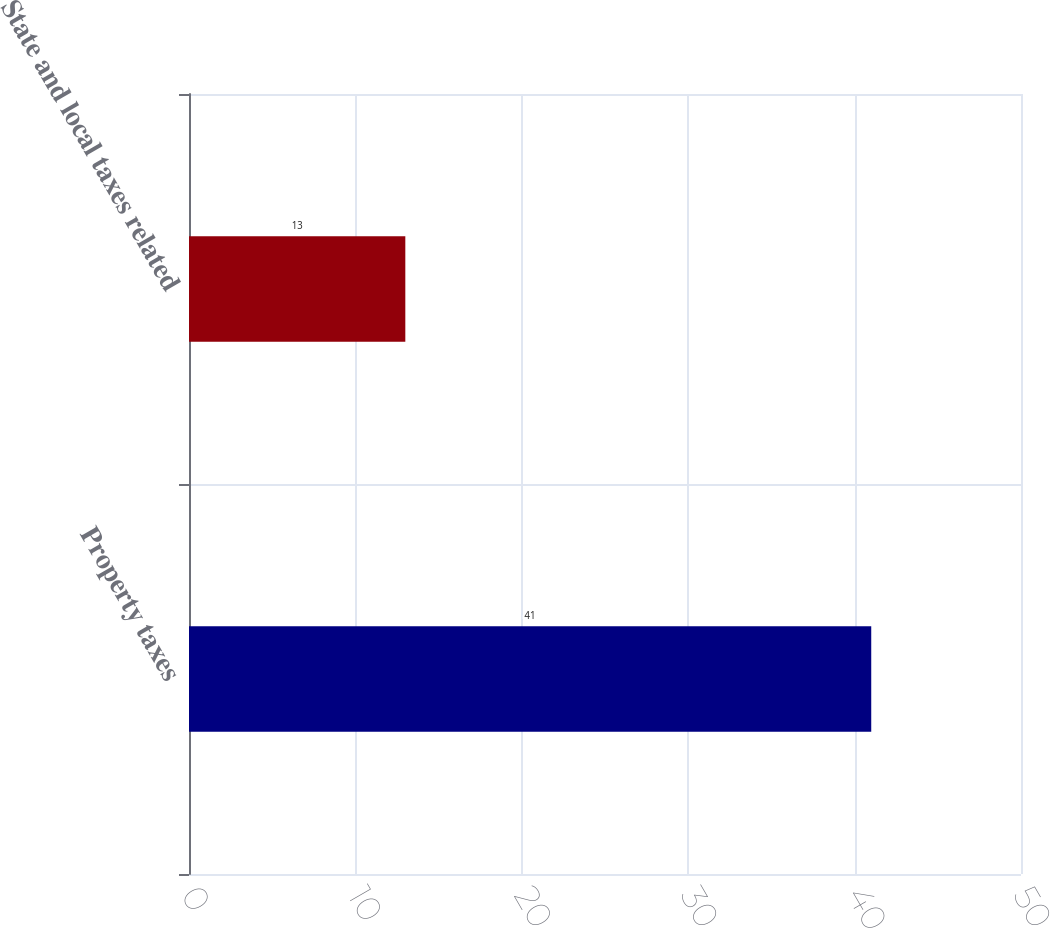Convert chart. <chart><loc_0><loc_0><loc_500><loc_500><bar_chart><fcel>Property taxes<fcel>State and local taxes related<nl><fcel>41<fcel>13<nl></chart> 